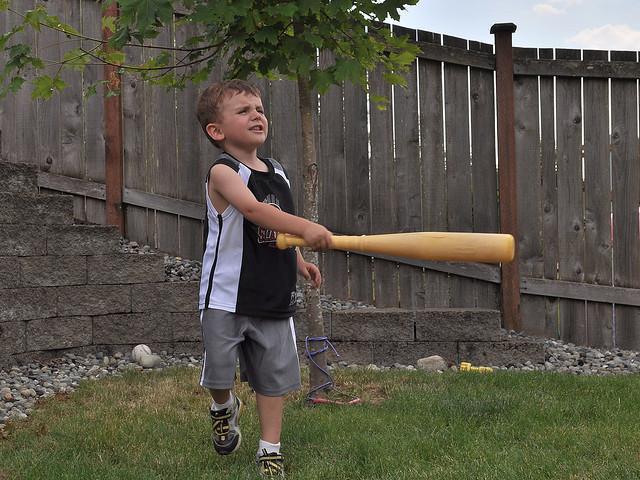How many children are there?
Give a very brief answer. 1. 